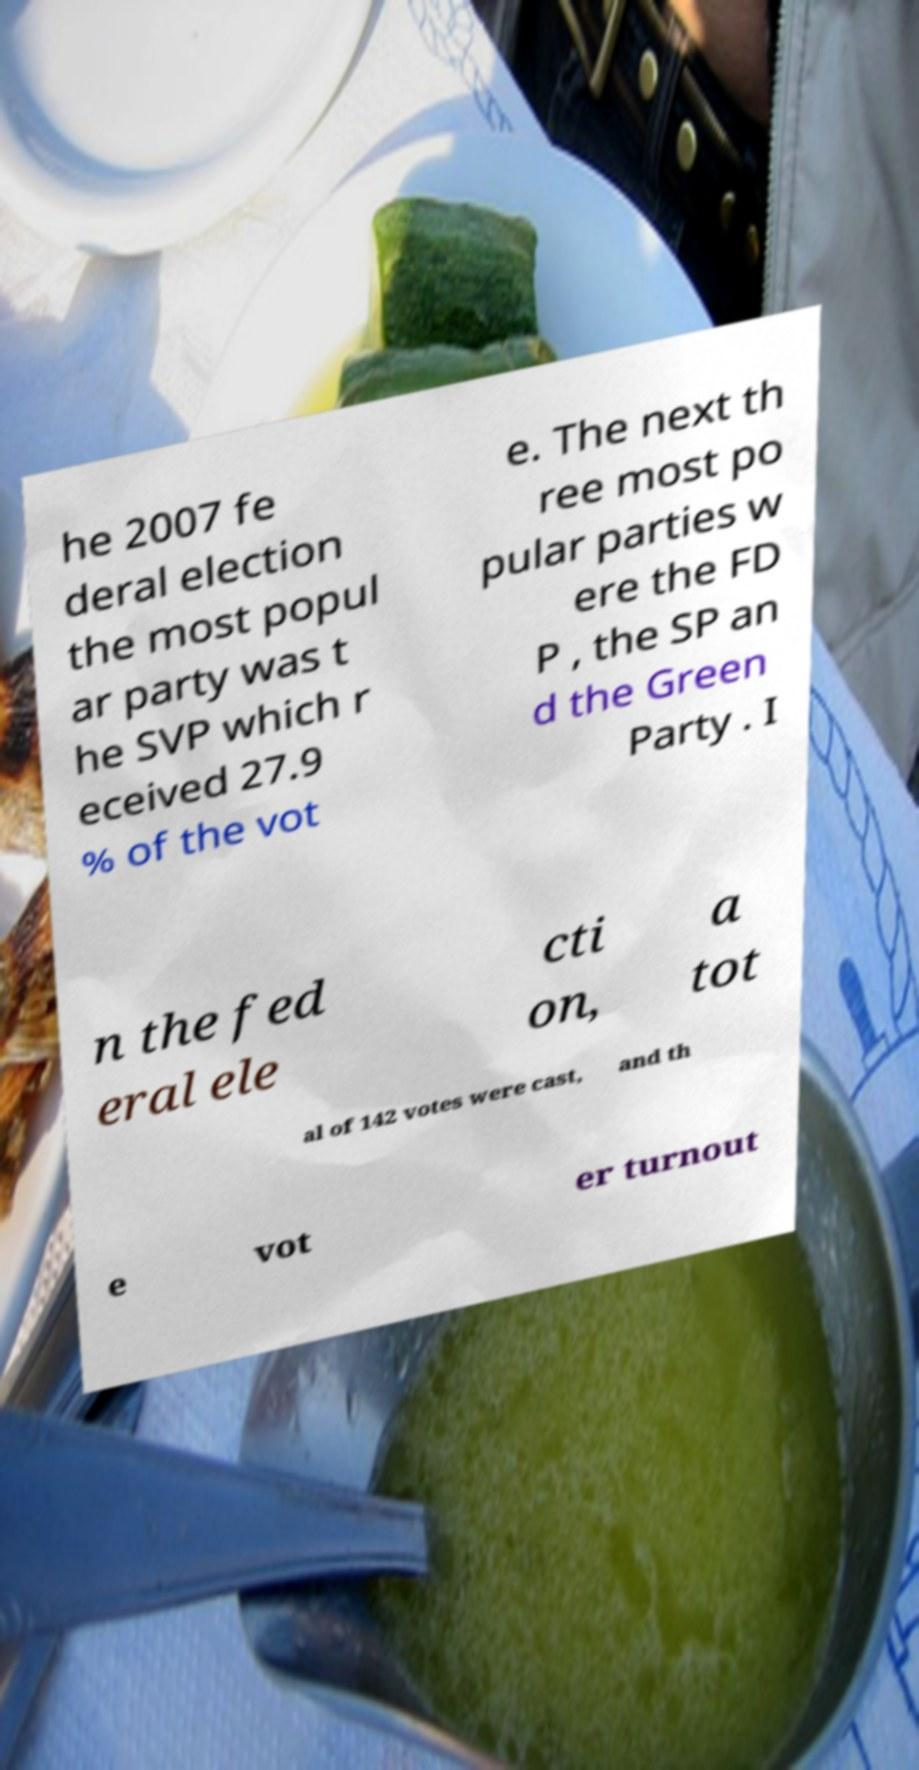What messages or text are displayed in this image? I need them in a readable, typed format. he 2007 fe deral election the most popul ar party was t he SVP which r eceived 27.9 % of the vot e. The next th ree most po pular parties w ere the FD P , the SP an d the Green Party . I n the fed eral ele cti on, a tot al of 142 votes were cast, and th e vot er turnout 